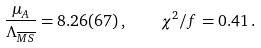<formula> <loc_0><loc_0><loc_500><loc_500>\frac { \mu _ { A } } { \Lambda _ { \overline { M S } } } = 8 . 2 6 ( 6 7 ) \, , \quad \chi ^ { 2 } / f = 0 . 4 1 \, .</formula> 